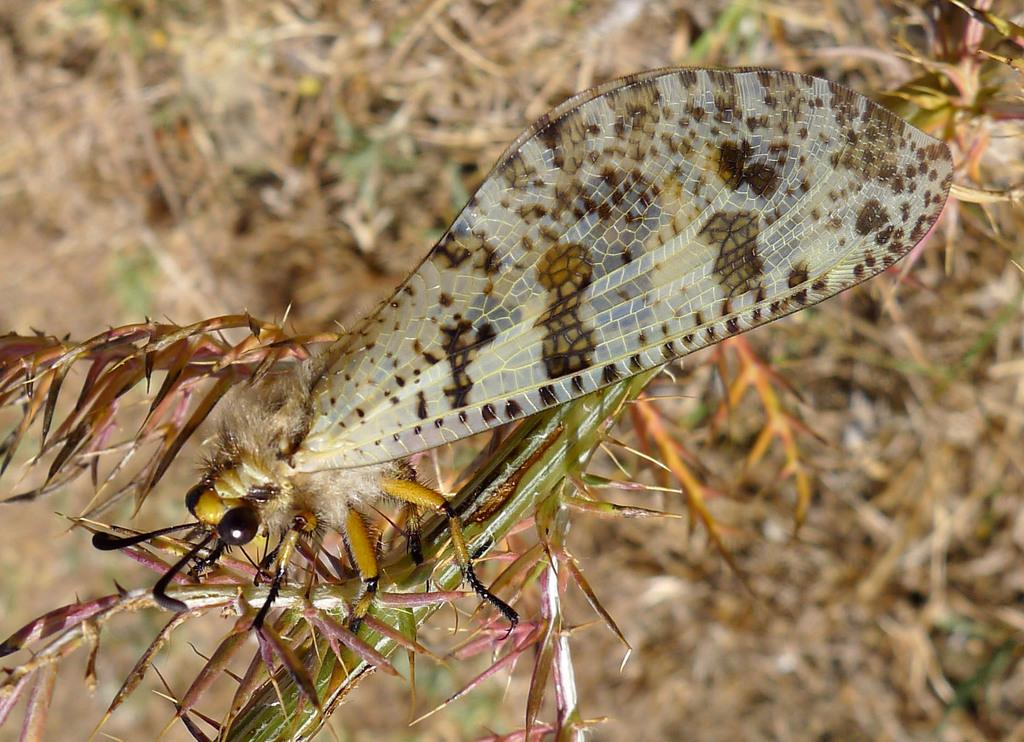What is present on the plant in the image? There is an insect on a plant in the image. How would you describe the appearance of the background in the image? The background of the image is blurred. What type of vegetation can be seen in the background of the image? Grass is visible in the background of the image. What type of canvas is the insect using to make its discovery in the image? There is no canvas or discovery present in the image; it features an insect on a plant with a blurred background and visible grass. 